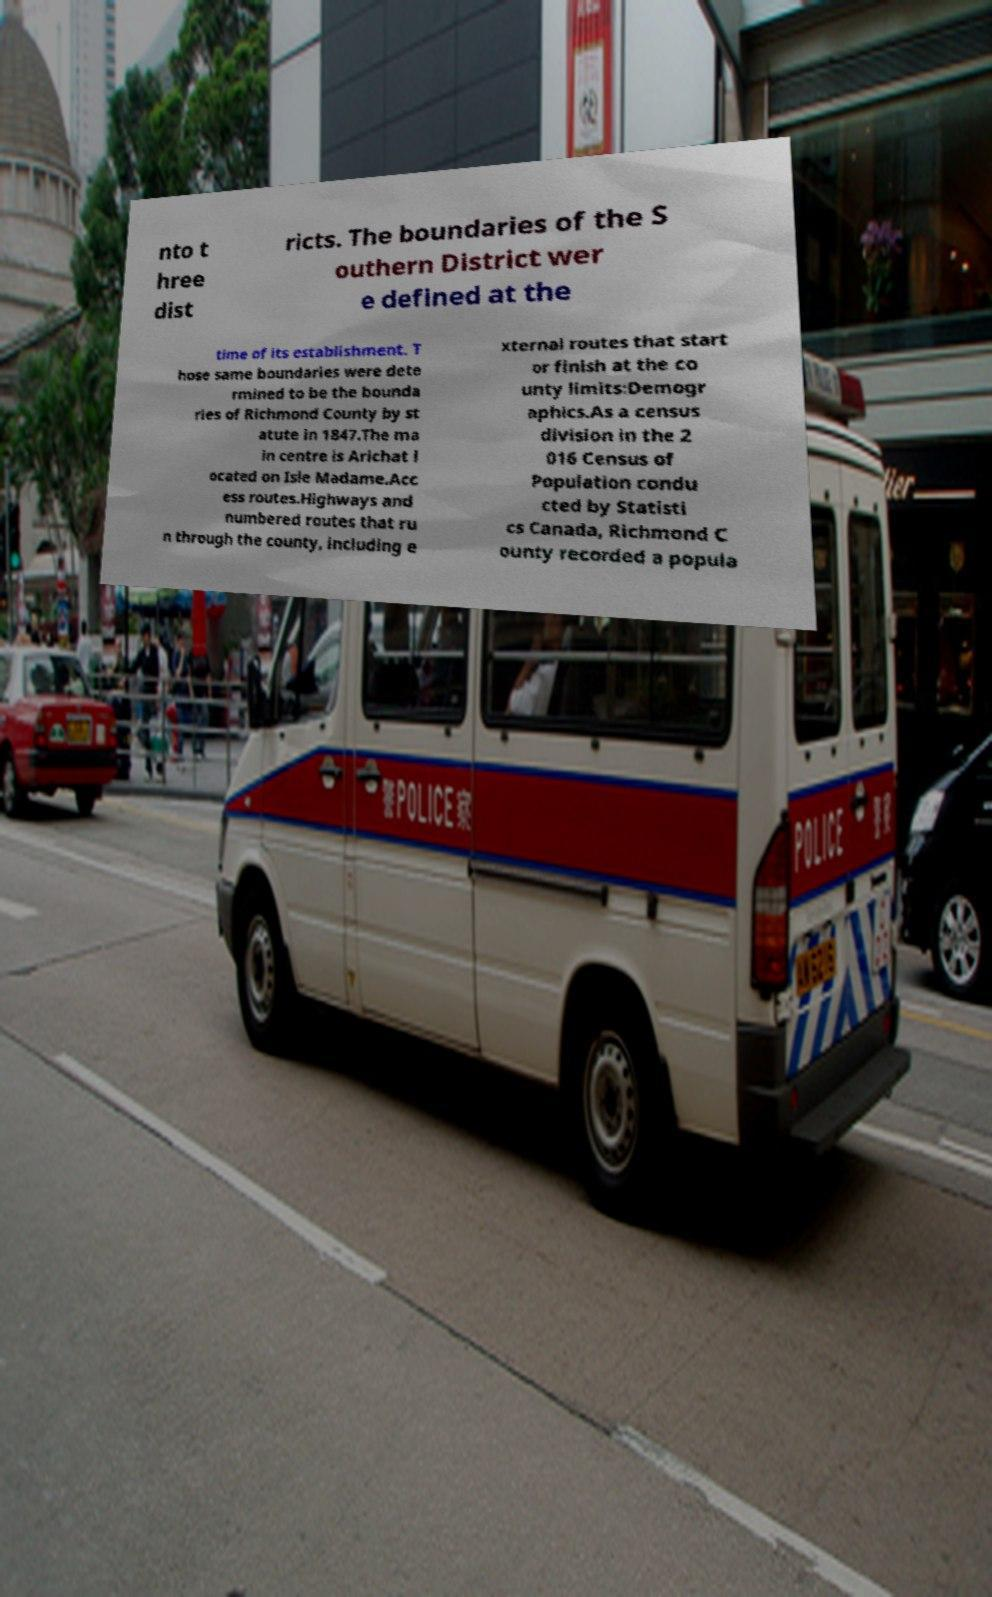Could you assist in decoding the text presented in this image and type it out clearly? nto t hree dist ricts. The boundaries of the S outhern District wer e defined at the time of its establishment. T hose same boundaries were dete rmined to be the bounda ries of Richmond County by st atute in 1847.The ma in centre is Arichat l ocated on Isle Madame.Acc ess routes.Highways and numbered routes that ru n through the county, including e xternal routes that start or finish at the co unty limits:Demogr aphics.As a census division in the 2 016 Census of Population condu cted by Statisti cs Canada, Richmond C ounty recorded a popula 